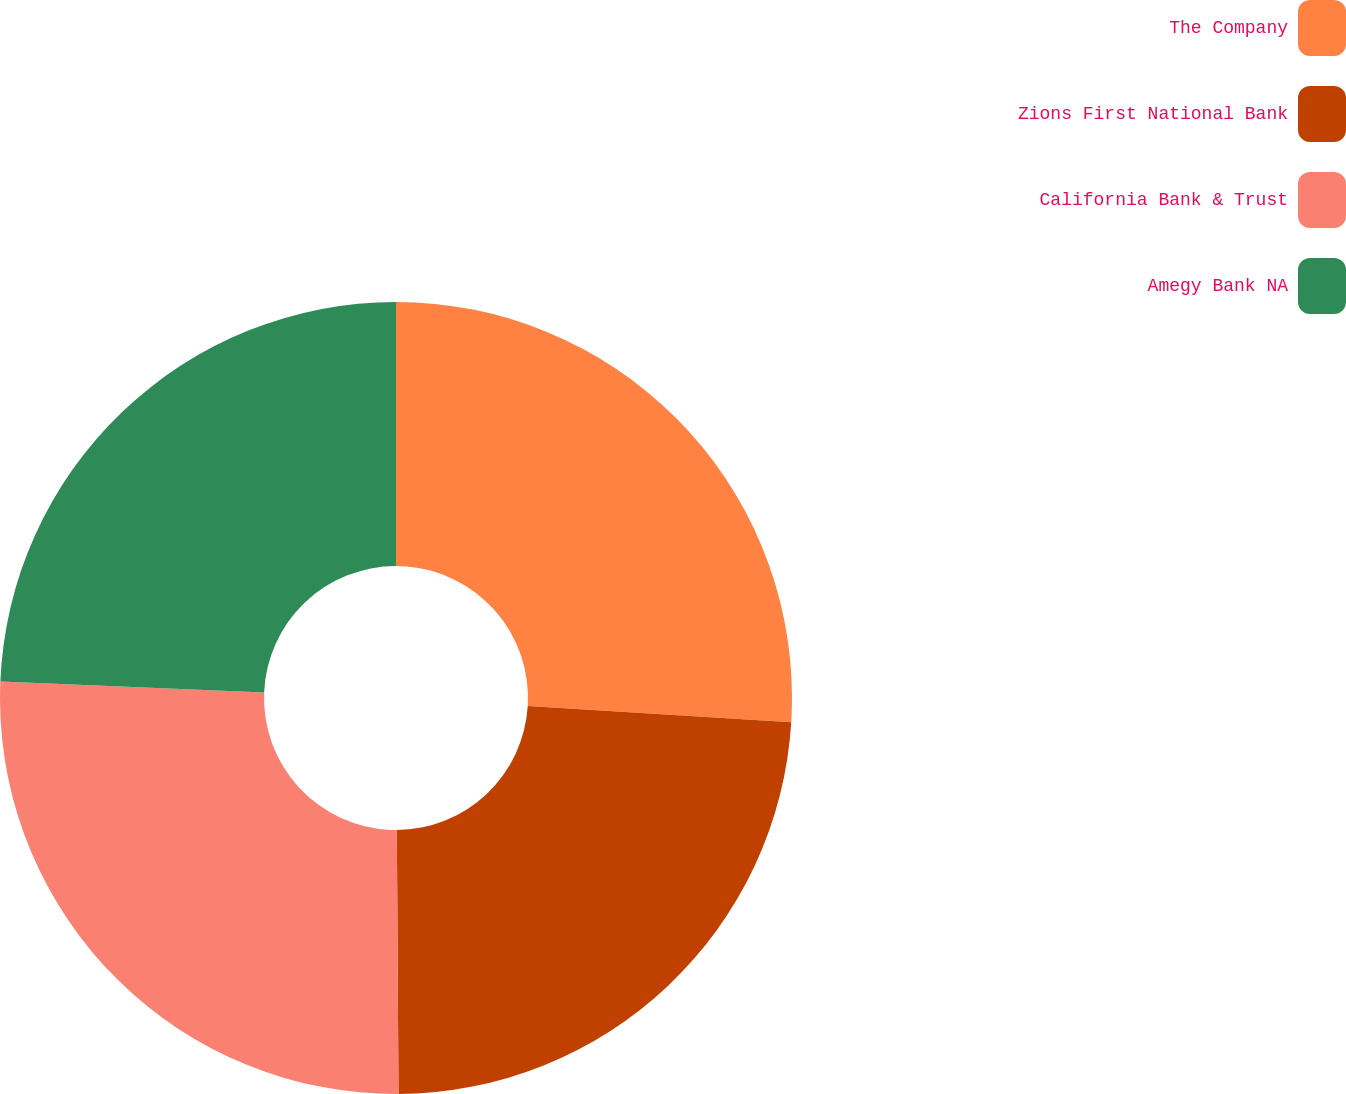Convert chart to OTSL. <chart><loc_0><loc_0><loc_500><loc_500><pie_chart><fcel>The Company<fcel>Zions First National Bank<fcel>California Bank & Trust<fcel>Amegy Bank NA<nl><fcel>25.98%<fcel>23.92%<fcel>25.76%<fcel>24.34%<nl></chart> 